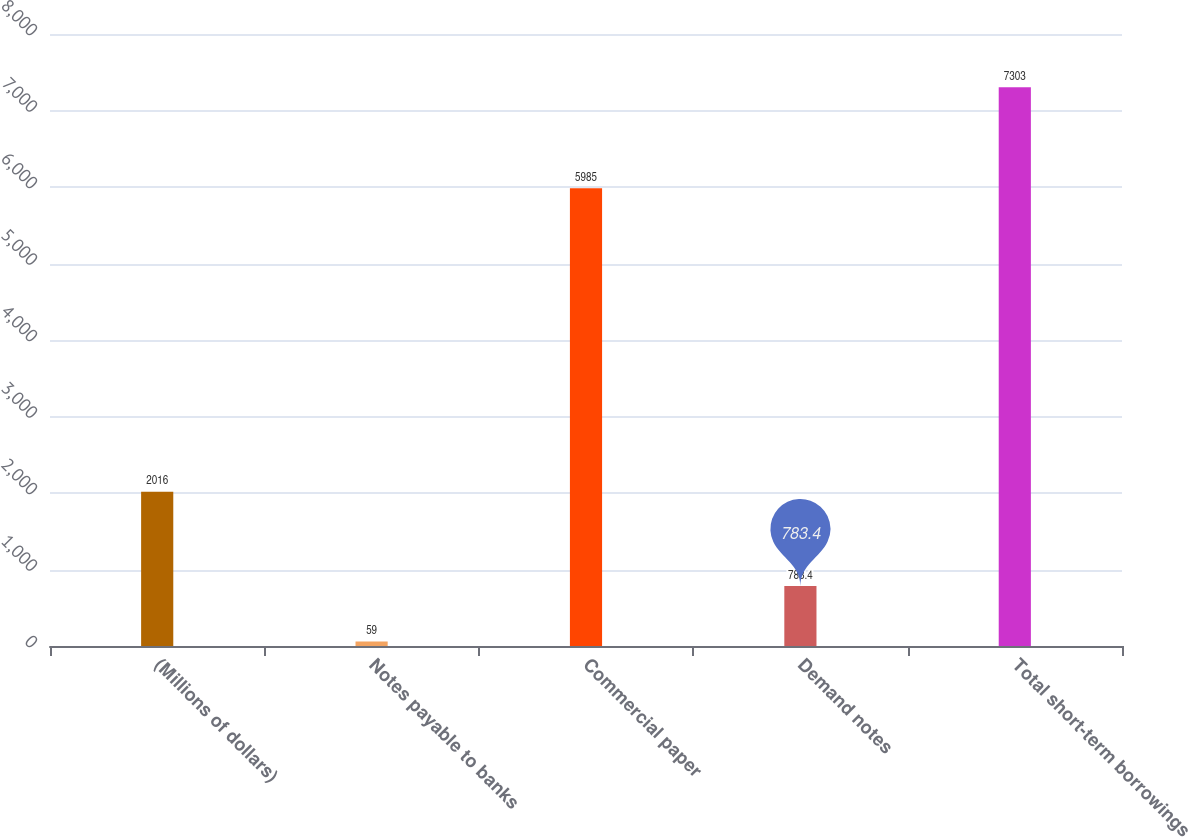<chart> <loc_0><loc_0><loc_500><loc_500><bar_chart><fcel>(Millions of dollars)<fcel>Notes payable to banks<fcel>Commercial paper<fcel>Demand notes<fcel>Total short-term borrowings<nl><fcel>2016<fcel>59<fcel>5985<fcel>783.4<fcel>7303<nl></chart> 